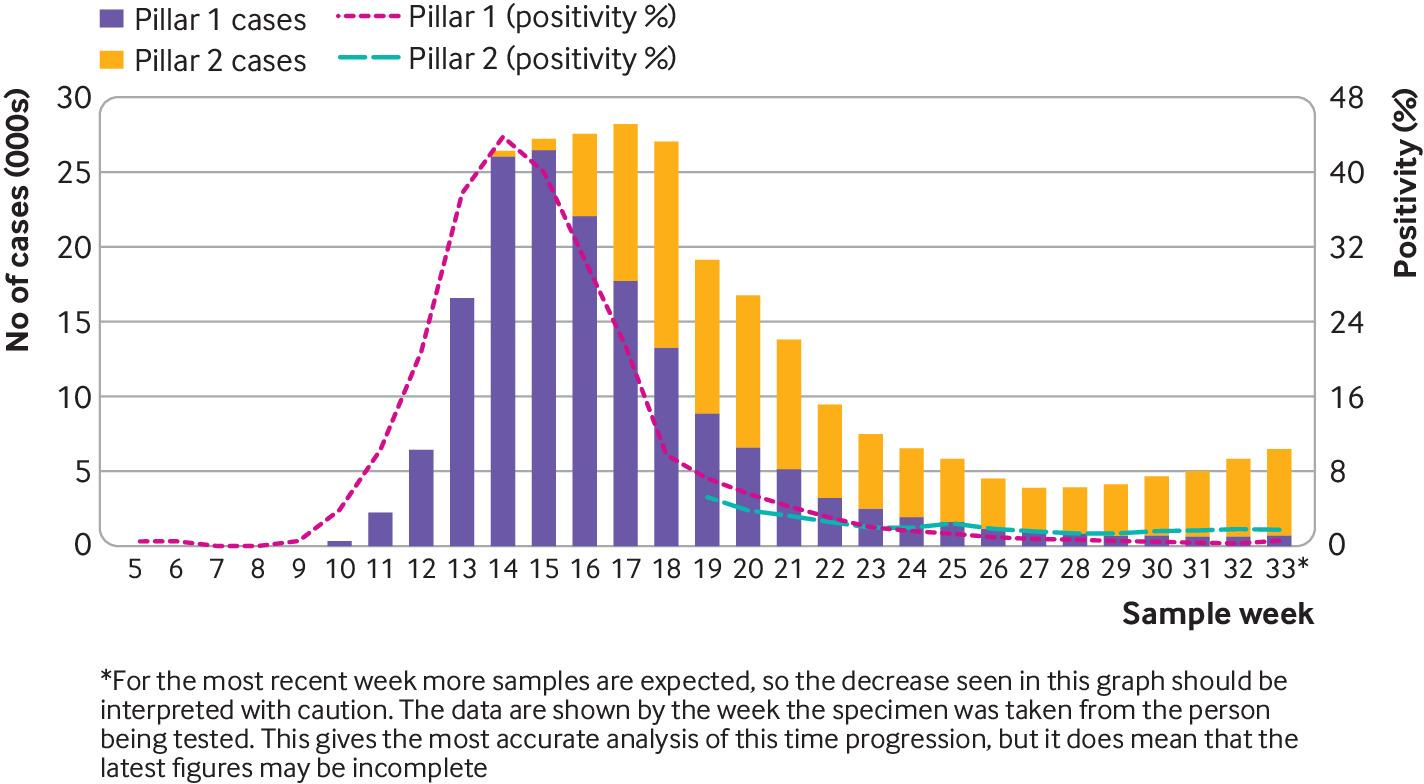Highlight a few significant elements in this photo. The total number of cases is 105. 